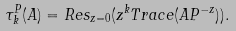<formula> <loc_0><loc_0><loc_500><loc_500>\tau ^ { P } _ { k } ( A ) = R e s _ { z = 0 } ( z ^ { k } T r a c e ( A P ^ { - z } ) ) .</formula> 